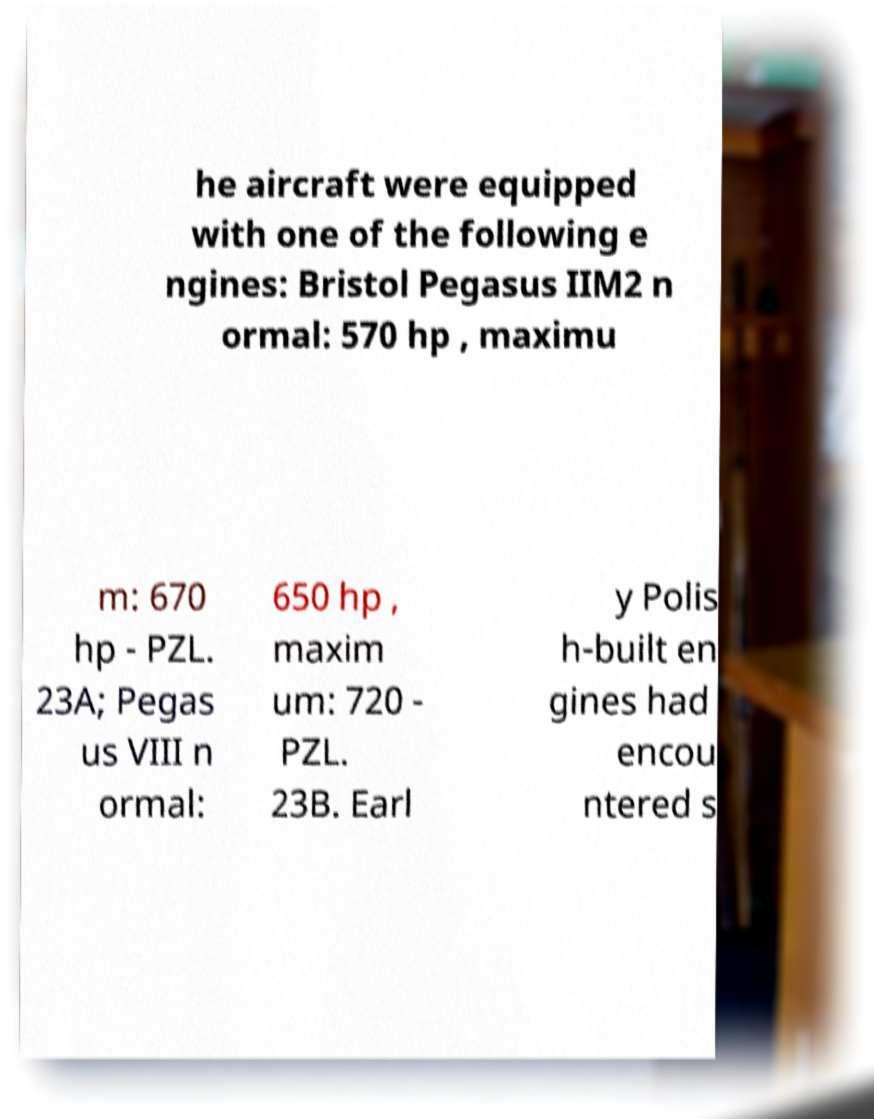There's text embedded in this image that I need extracted. Can you transcribe it verbatim? he aircraft were equipped with one of the following e ngines: Bristol Pegasus IIM2 n ormal: 570 hp , maximu m: 670 hp - PZL. 23A; Pegas us VIII n ormal: 650 hp , maxim um: 720 - PZL. 23B. Earl y Polis h-built en gines had encou ntered s 